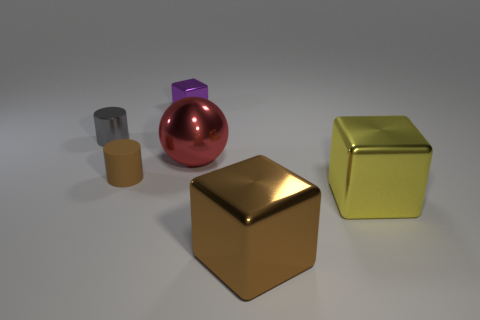The gray metallic thing that is the same shape as the brown rubber thing is what size?
Offer a very short reply. Small. Is there anything else that has the same size as the gray metallic cylinder?
Provide a short and direct response. Yes. How many things are either objects right of the tiny purple shiny object or blocks to the left of the red metallic ball?
Offer a very short reply. 4. Does the purple object have the same size as the yellow metallic thing?
Your response must be concise. No. Is the number of tiny red rubber objects greater than the number of small gray metallic things?
Offer a very short reply. No. What number of other objects are the same color as the big shiny sphere?
Offer a very short reply. 0. How many things are either big metal balls or matte objects?
Your answer should be compact. 2. Does the object that is behind the tiny gray metallic cylinder have the same shape as the gray shiny object?
Offer a very short reply. No. What color is the small cylinder that is behind the big shiny object that is behind the brown rubber thing?
Provide a succinct answer. Gray. Are there fewer metallic balls than red rubber blocks?
Your response must be concise. No. 